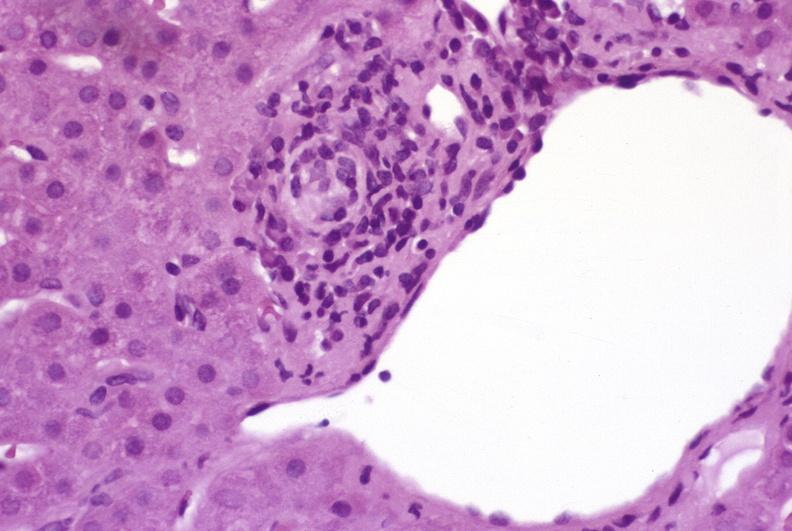s hepatobiliary present?
Answer the question using a single word or phrase. Yes 